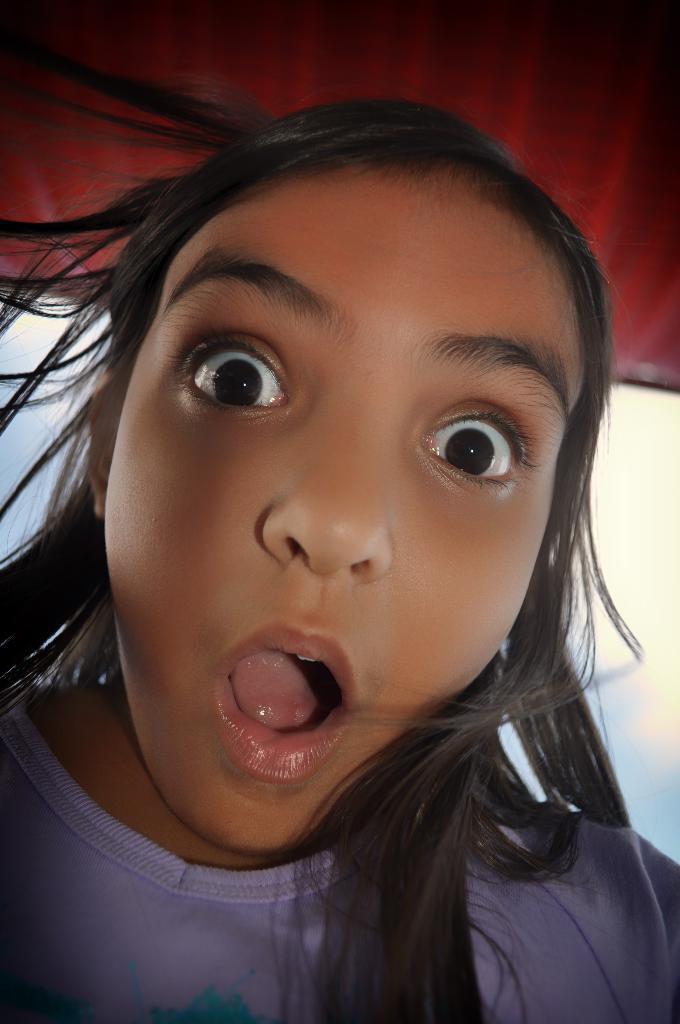Please provide a concise description of this image. In the middle of the image there is a girl with a weird expression on her face. In the background there is the sky with clouds. At the top of the image there is an object. 